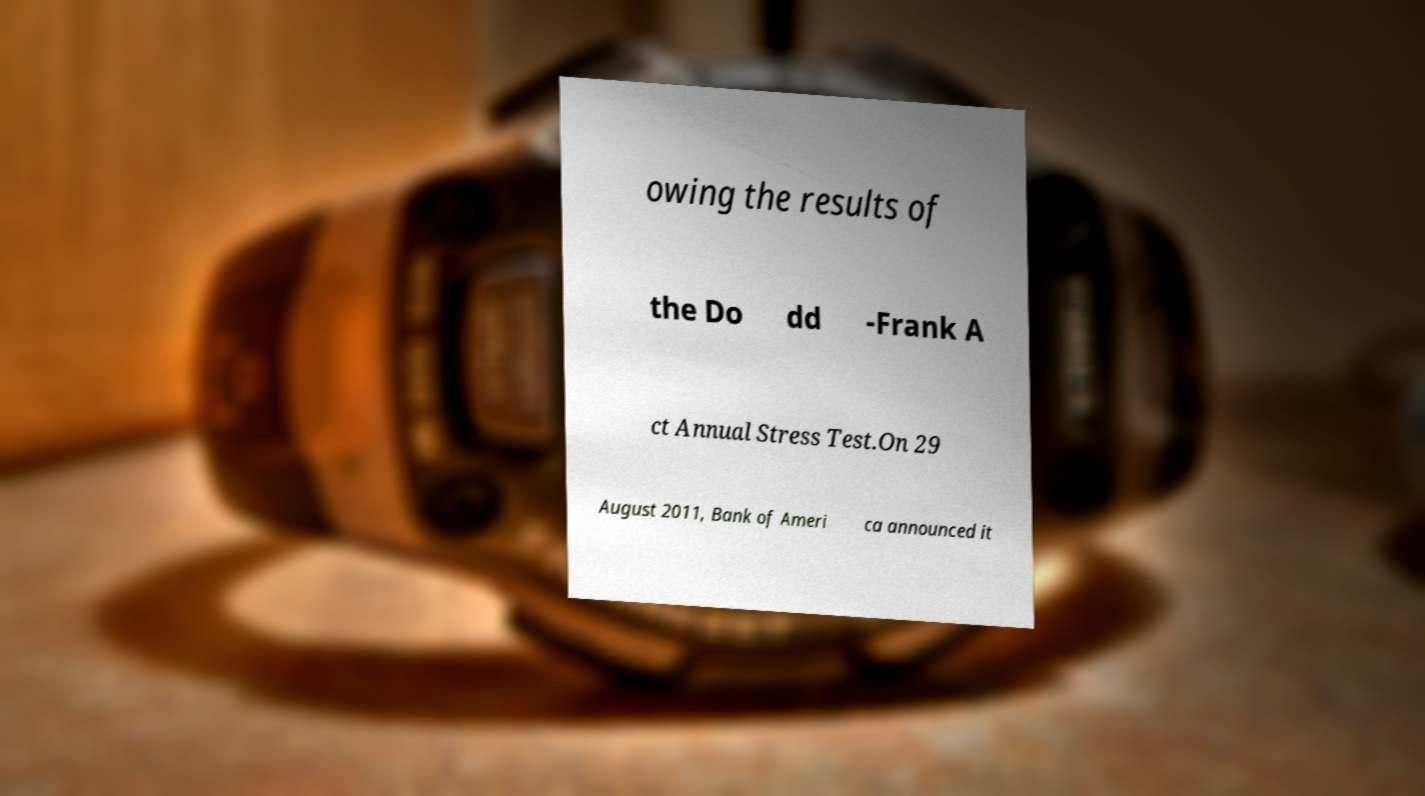Please identify and transcribe the text found in this image. owing the results of the Do dd -Frank A ct Annual Stress Test.On 29 August 2011, Bank of Ameri ca announced it 